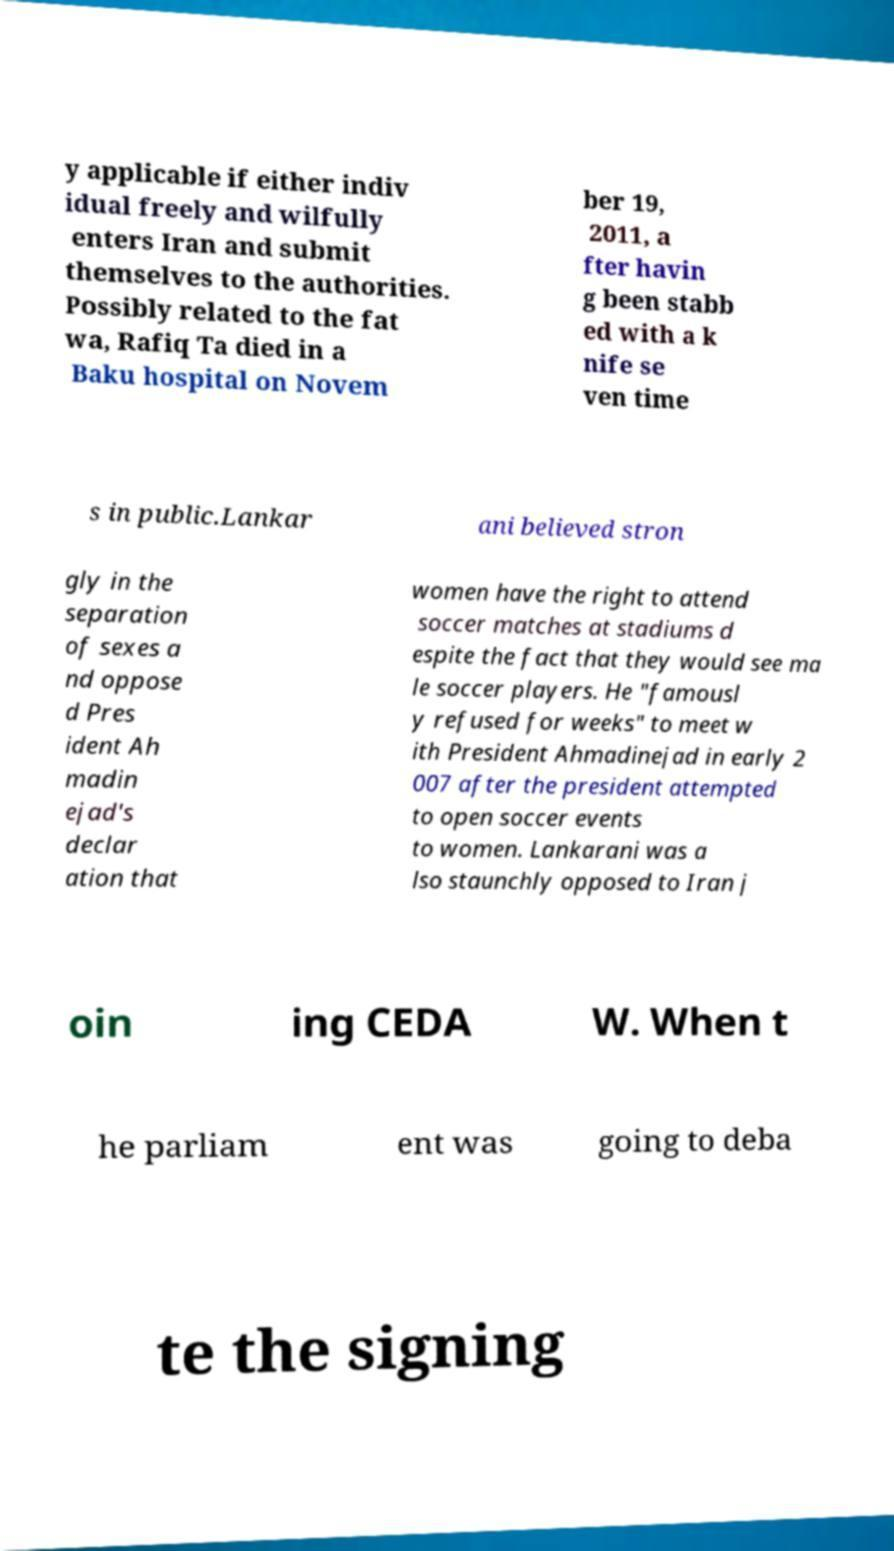Could you extract and type out the text from this image? y applicable if either indiv idual freely and wilfully enters Iran and submit themselves to the authorities. Possibly related to the fat wa, Rafiq Ta died in a Baku hospital on Novem ber 19, 2011, a fter havin g been stabb ed with a k nife se ven time s in public.Lankar ani believed stron gly in the separation of sexes a nd oppose d Pres ident Ah madin ejad's declar ation that women have the right to attend soccer matches at stadiums d espite the fact that they would see ma le soccer players. He "famousl y refused for weeks" to meet w ith President Ahmadinejad in early 2 007 after the president attempted to open soccer events to women. Lankarani was a lso staunchly opposed to Iran j oin ing CEDA W. When t he parliam ent was going to deba te the signing 